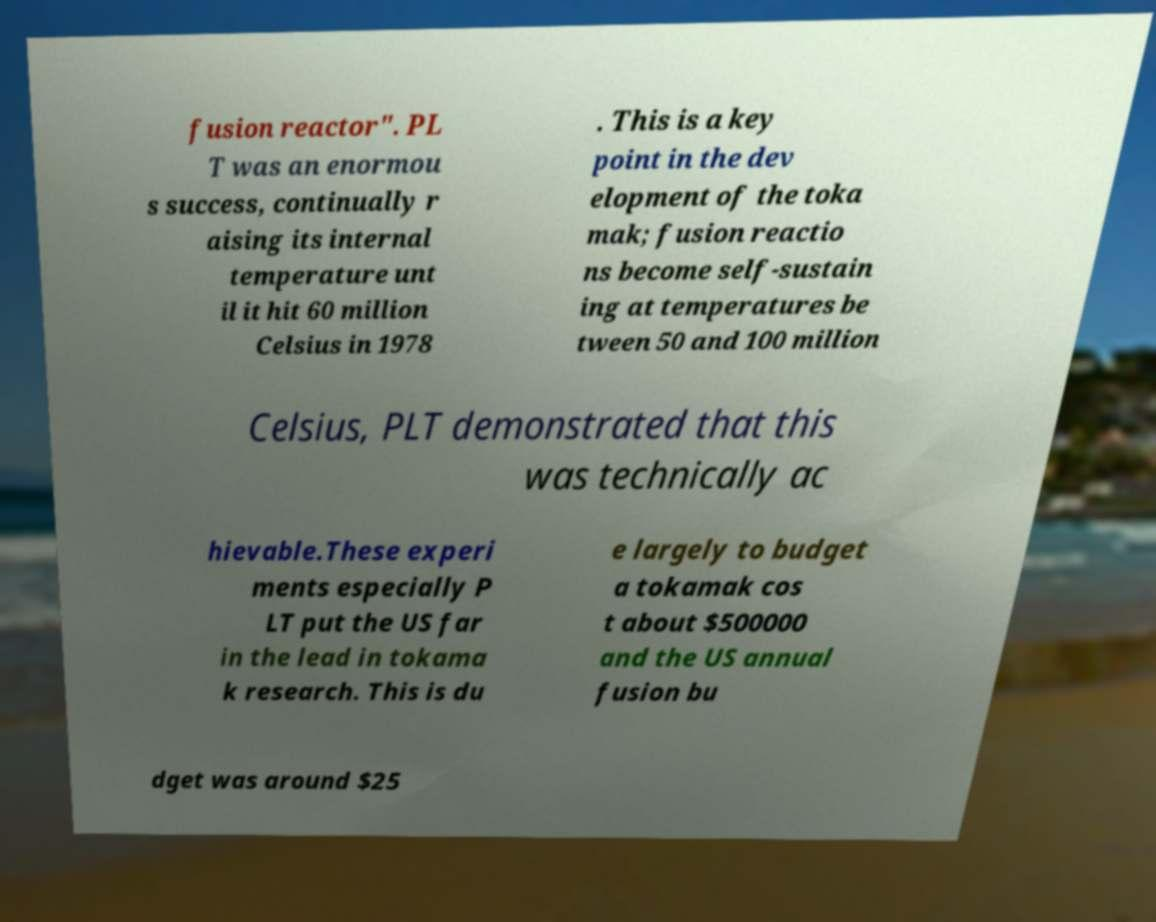Can you accurately transcribe the text from the provided image for me? fusion reactor". PL T was an enormou s success, continually r aising its internal temperature unt il it hit 60 million Celsius in 1978 . This is a key point in the dev elopment of the toka mak; fusion reactio ns become self-sustain ing at temperatures be tween 50 and 100 million Celsius, PLT demonstrated that this was technically ac hievable.These experi ments especially P LT put the US far in the lead in tokama k research. This is du e largely to budget a tokamak cos t about $500000 and the US annual fusion bu dget was around $25 